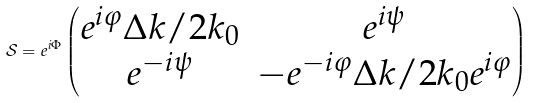<formula> <loc_0><loc_0><loc_500><loc_500>\mathcal { S } = e ^ { i \Phi } \begin{pmatrix} e ^ { i \varphi } \Delta k / 2 k _ { 0 } & e ^ { i \psi } \\ e ^ { - i \psi } & - e ^ { - i \varphi } \Delta k / 2 k _ { 0 } e ^ { i \varphi } \end{pmatrix}</formula> 